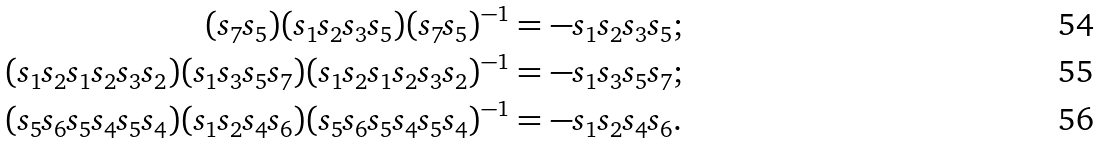<formula> <loc_0><loc_0><loc_500><loc_500>( s _ { 7 } s _ { 5 } ) ( s _ { 1 } s _ { 2 } s _ { 3 } s _ { 5 } ) ( s _ { 7 } s _ { 5 } ) ^ { - 1 } & = - s _ { 1 } s _ { 2 } s _ { 3 } s _ { 5 } ; \\ ( s _ { 1 } s _ { 2 } s _ { 1 } s _ { 2 } s _ { 3 } s _ { 2 } ) ( s _ { 1 } s _ { 3 } s _ { 5 } s _ { 7 } ) ( s _ { 1 } s _ { 2 } s _ { 1 } s _ { 2 } s _ { 3 } s _ { 2 } ) ^ { - 1 } & = - s _ { 1 } s _ { 3 } s _ { 5 } s _ { 7 } ; \\ ( s _ { 5 } s _ { 6 } s _ { 5 } s _ { 4 } s _ { 5 } s _ { 4 } ) ( s _ { 1 } s _ { 2 } s _ { 4 } s _ { 6 } ) ( s _ { 5 } s _ { 6 } s _ { 5 } s _ { 4 } s _ { 5 } s _ { 4 } ) ^ { - 1 } & = - s _ { 1 } s _ { 2 } s _ { 4 } s _ { 6 } .</formula> 